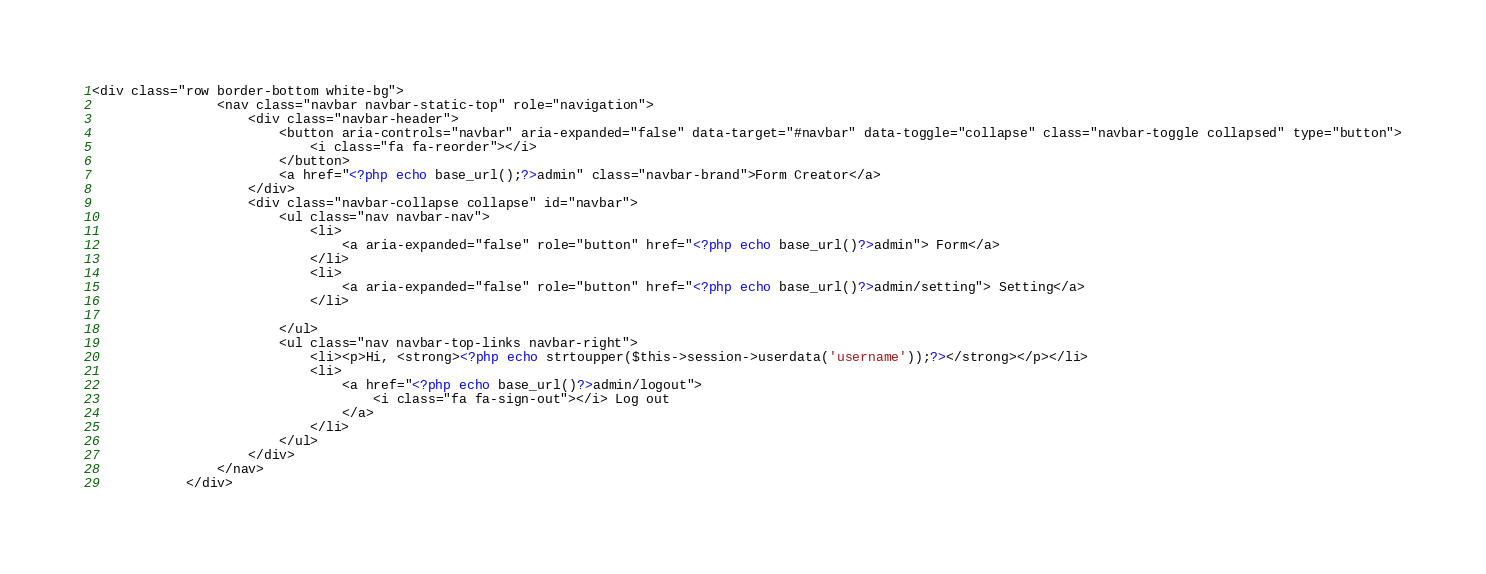Convert code to text. <code><loc_0><loc_0><loc_500><loc_500><_PHP_><div class="row border-bottom white-bg">
                <nav class="navbar navbar-static-top" role="navigation">
                    <div class="navbar-header">
                        <button aria-controls="navbar" aria-expanded="false" data-target="#navbar" data-toggle="collapse" class="navbar-toggle collapsed" type="button">
                            <i class="fa fa-reorder"></i>
                        </button>
                        <a href="<?php echo base_url();?>admin" class="navbar-brand">Form Creator</a>
                    </div>
                    <div class="navbar-collapse collapse" id="navbar">
                        <ul class="nav navbar-nav">
                            <li>
                                <a aria-expanded="false" role="button" href="<?php echo base_url()?>admin"> Form</a>
                            </li>
                            <li>
                                <a aria-expanded="false" role="button" href="<?php echo base_url()?>admin/setting"> Setting</a>
                            </li>

                        </ul>
                        <ul class="nav navbar-top-links navbar-right">
                            <li><p>Hi, <strong><?php echo strtoupper($this->session->userdata('username'));?></strong></p></li>
                            <li>
                                <a href="<?php echo base_url()?>admin/logout">
                                    <i class="fa fa-sign-out"></i> Log out
                                </a>
                            </li>
                        </ul>
                    </div>
                </nav>
            </div></code> 